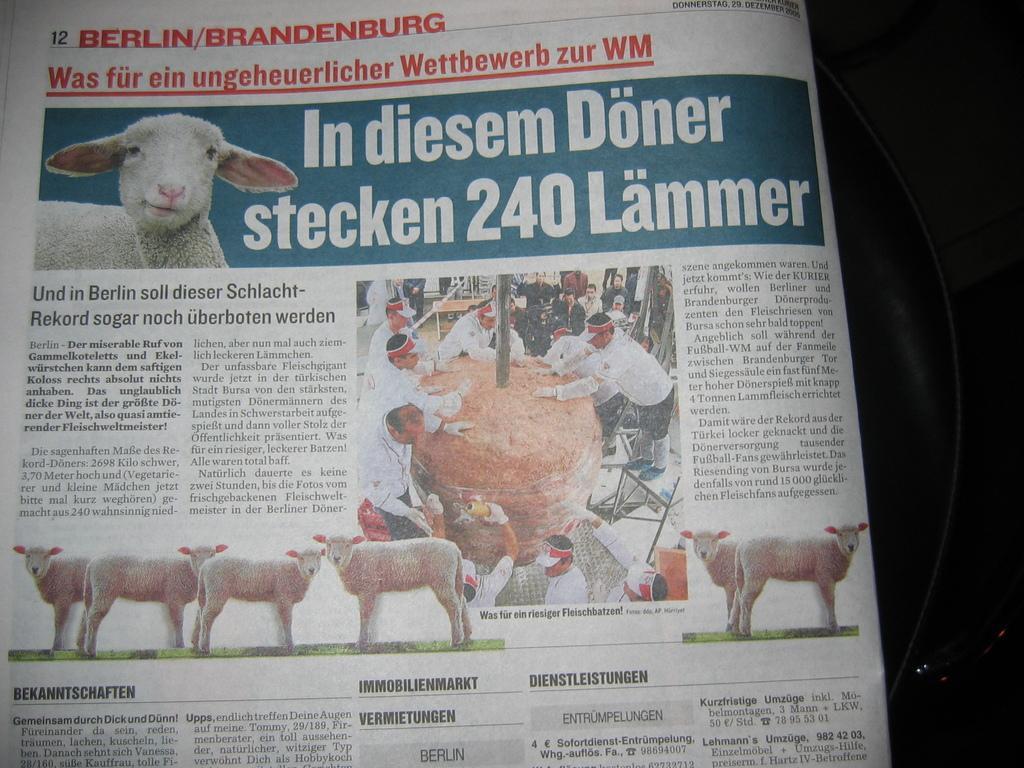Please provide a concise description of this image. In this picture we can see a paper, there is some text on this paper, we can also see pictures of sheep and some people on this paper. 